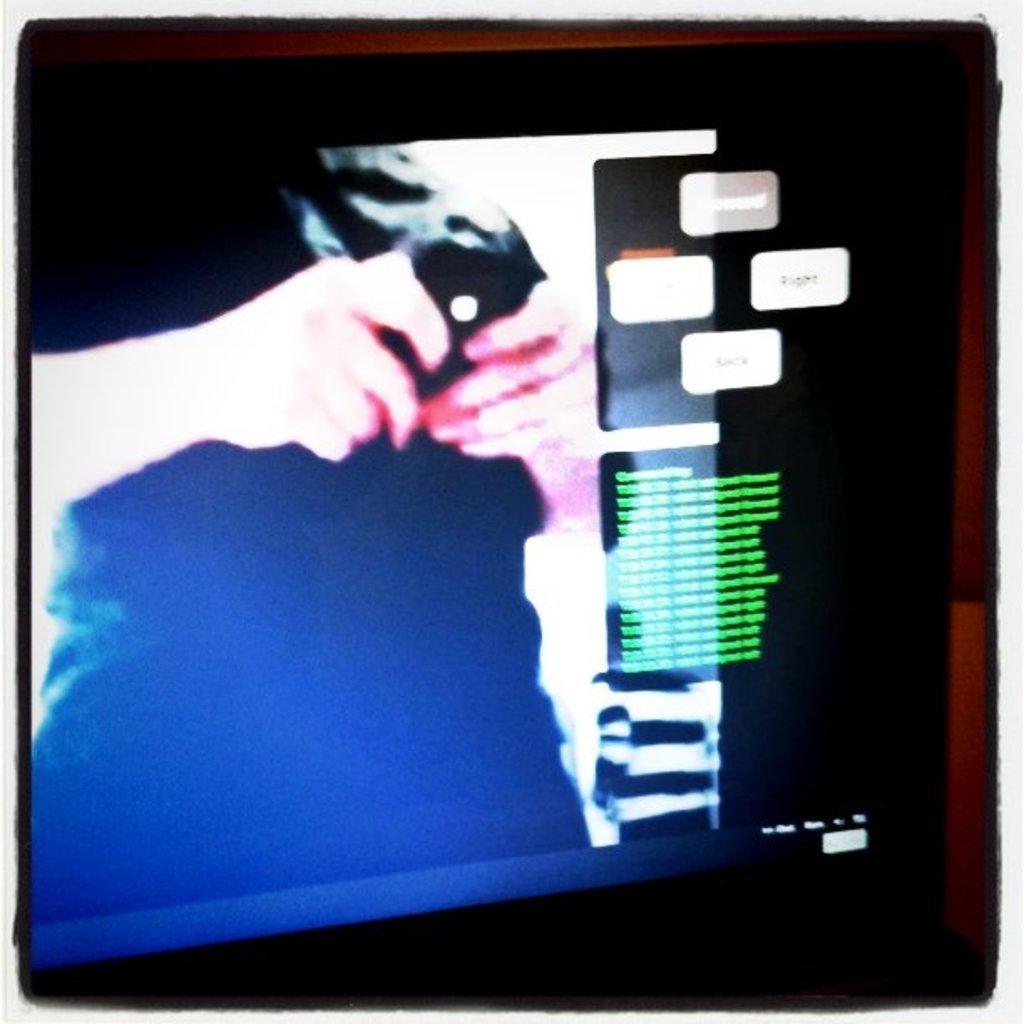In one or two sentences, can you explain what this image depicts? This is an edited picture. In this image there is a picture of a person standing and holding the object on the screen and there is text on the screen. 